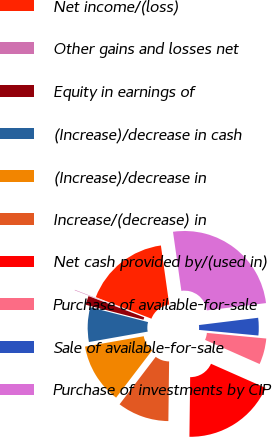<chart> <loc_0><loc_0><loc_500><loc_500><pie_chart><fcel>Net income/(loss)<fcel>Other gains and losses net<fcel>Equity in earnings of<fcel>(Increase)/decrease in cash<fcel>(Increase)/decrease in<fcel>Increase/(decrease) in<fcel>Net cash provided by/(used in)<fcel>Purchase of available-for-sale<fcel>Sale of available-for-sale<fcel>Purchase of investments by CIP<nl><fcel>16.89%<fcel>0.09%<fcel>1.77%<fcel>6.81%<fcel>11.85%<fcel>10.17%<fcel>18.57%<fcel>5.13%<fcel>3.45%<fcel>25.29%<nl></chart> 